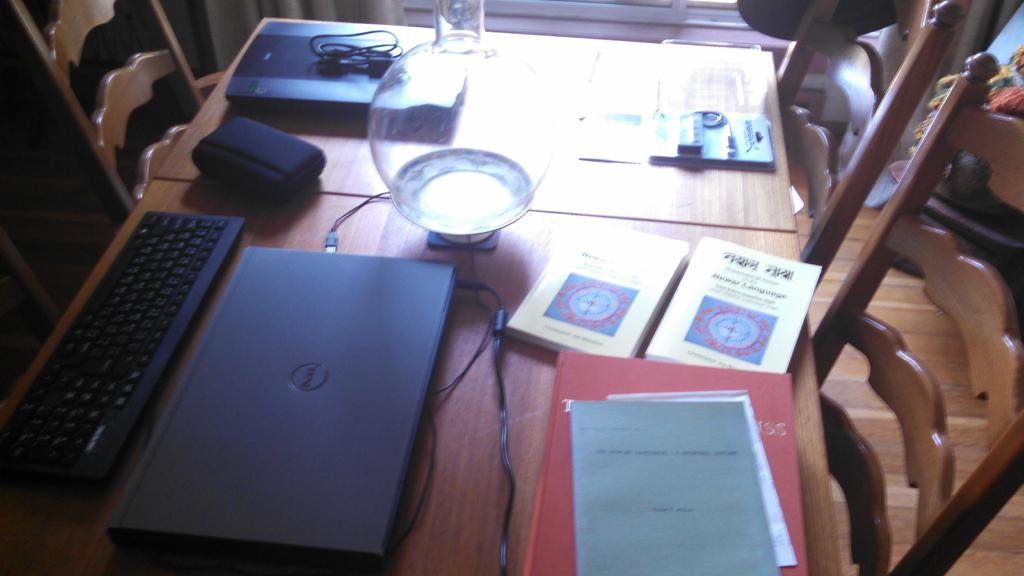What objects related to learning or work can be seen in the image? There are books, a laptop, and a keyboard in the image. What type of beverage container is on the table in the image? There is a glass on the table in the image. What type of furniture is present in the image? There are chairs in the image. What type of wheel is visible in the image? There is no wheel present in the image. What advice can be seen written on the books in the image? The books in the image do not contain any visible advice; they are simply books. 